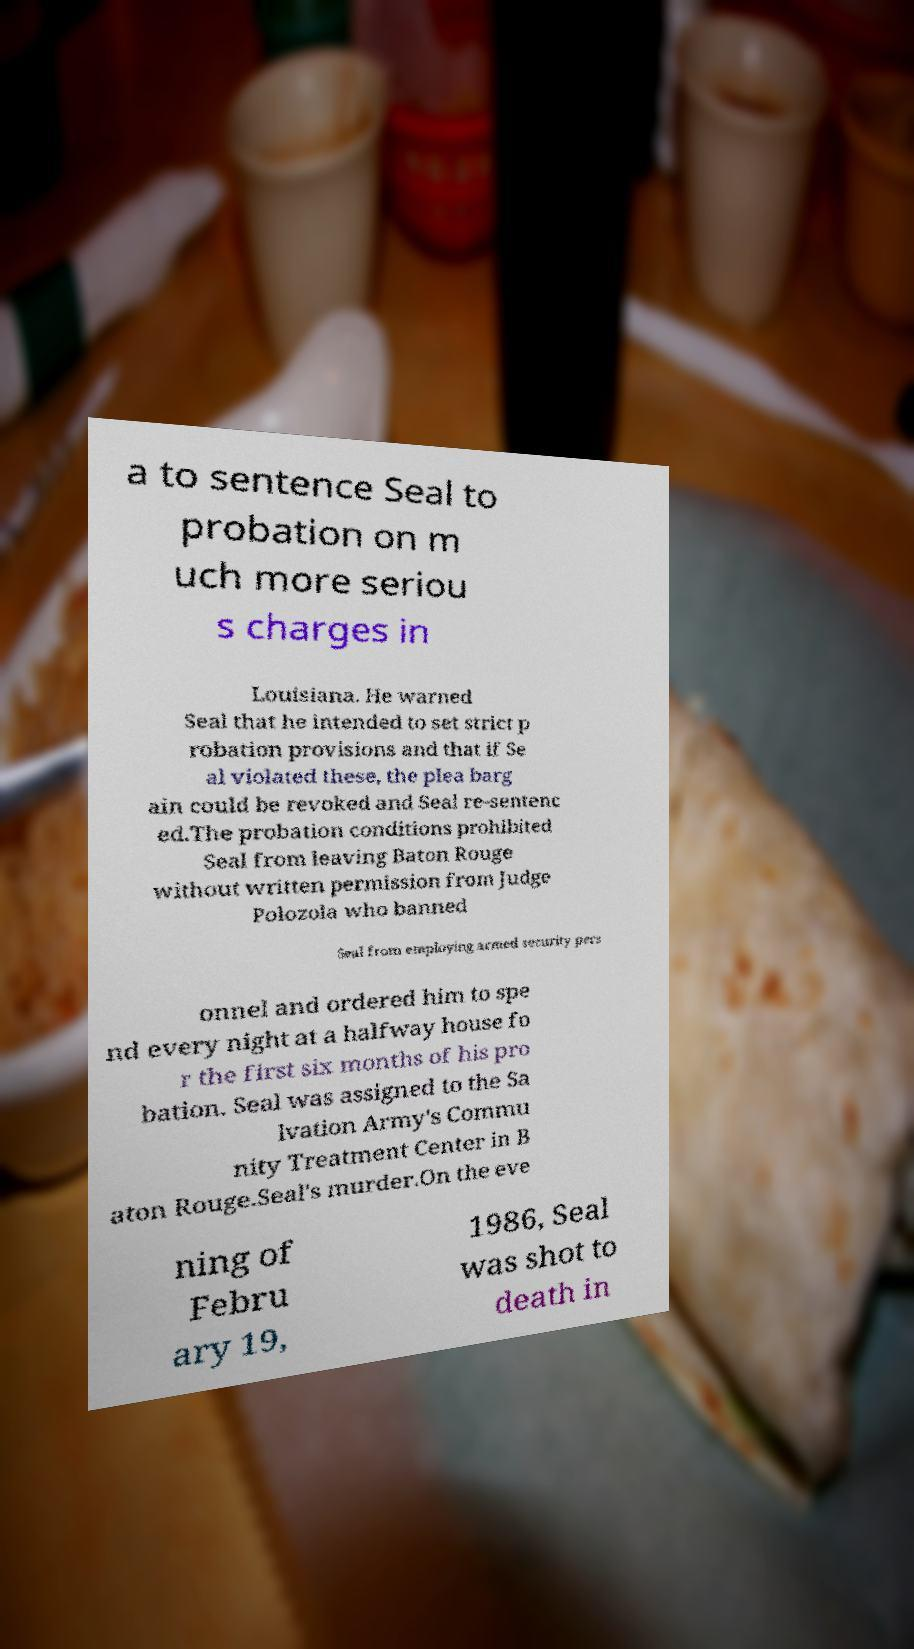Could you assist in decoding the text presented in this image and type it out clearly? a to sentence Seal to probation on m uch more seriou s charges in Louisiana. He warned Seal that he intended to set strict p robation provisions and that if Se al violated these, the plea barg ain could be revoked and Seal re-sentenc ed.The probation conditions prohibited Seal from leaving Baton Rouge without written permission from Judge Polozola who banned Seal from employing armed security pers onnel and ordered him to spe nd every night at a halfway house fo r the first six months of his pro bation. Seal was assigned to the Sa lvation Army's Commu nity Treatment Center in B aton Rouge.Seal's murder.On the eve ning of Febru ary 19, 1986, Seal was shot to death in 